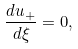Convert formula to latex. <formula><loc_0><loc_0><loc_500><loc_500>\frac { d u _ { + } } { d \xi } = 0 ,</formula> 